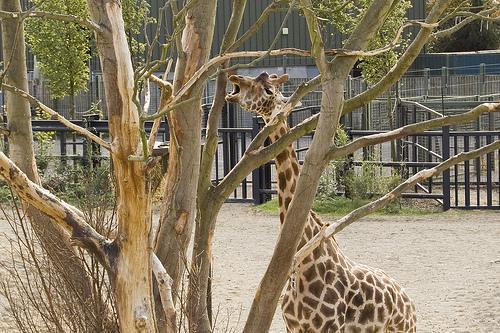How many giraffe are there?
Give a very brief answer. 1. 